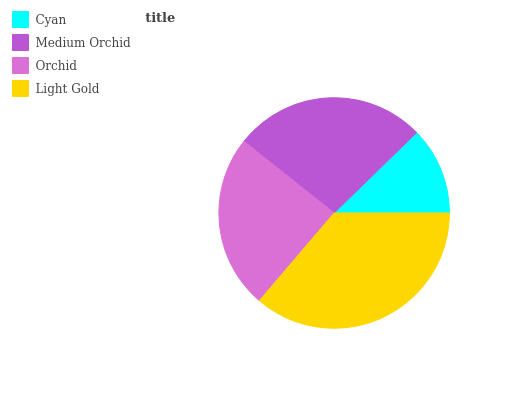Is Cyan the minimum?
Answer yes or no. Yes. Is Light Gold the maximum?
Answer yes or no. Yes. Is Medium Orchid the minimum?
Answer yes or no. No. Is Medium Orchid the maximum?
Answer yes or no. No. Is Medium Orchid greater than Cyan?
Answer yes or no. Yes. Is Cyan less than Medium Orchid?
Answer yes or no. Yes. Is Cyan greater than Medium Orchid?
Answer yes or no. No. Is Medium Orchid less than Cyan?
Answer yes or no. No. Is Medium Orchid the high median?
Answer yes or no. Yes. Is Orchid the low median?
Answer yes or no. Yes. Is Cyan the high median?
Answer yes or no. No. Is Medium Orchid the low median?
Answer yes or no. No. 